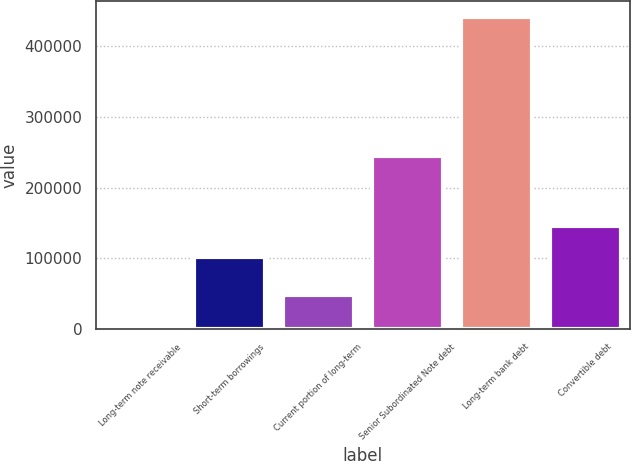Convert chart to OTSL. <chart><loc_0><loc_0><loc_500><loc_500><bar_chart><fcel>Long-term note receivable<fcel>Short-term borrowings<fcel>Current portion of long-term<fcel>Senior Subordinated Note debt<fcel>Long-term bank debt<fcel>Convertible debt<nl><fcel>4758<fcel>102267<fcel>48464<fcel>244375<fcel>441818<fcel>145973<nl></chart> 